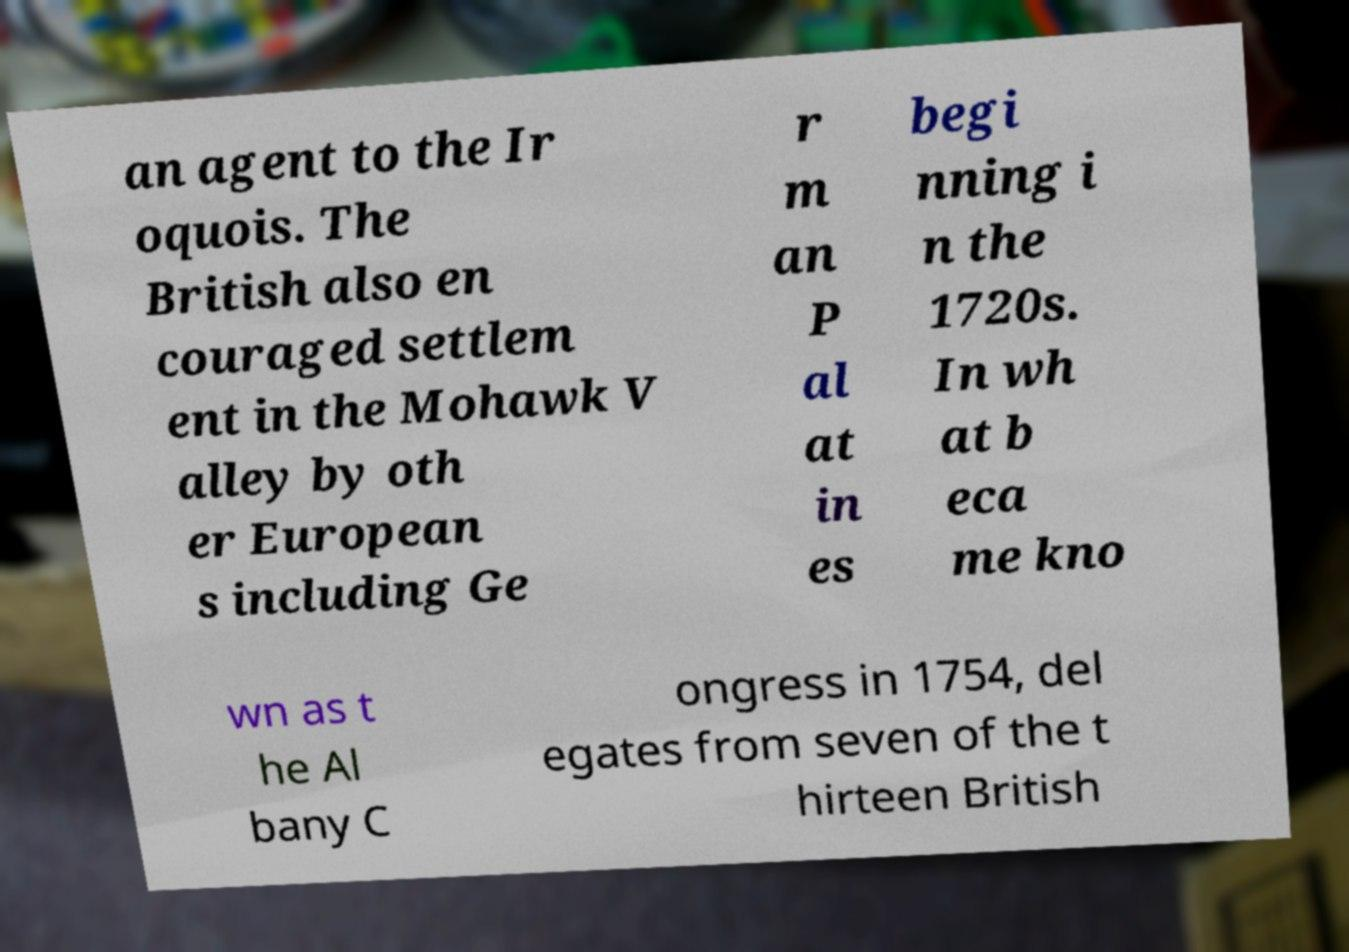Please identify and transcribe the text found in this image. an agent to the Ir oquois. The British also en couraged settlem ent in the Mohawk V alley by oth er European s including Ge r m an P al at in es begi nning i n the 1720s. In wh at b eca me kno wn as t he Al bany C ongress in 1754, del egates from seven of the t hirteen British 